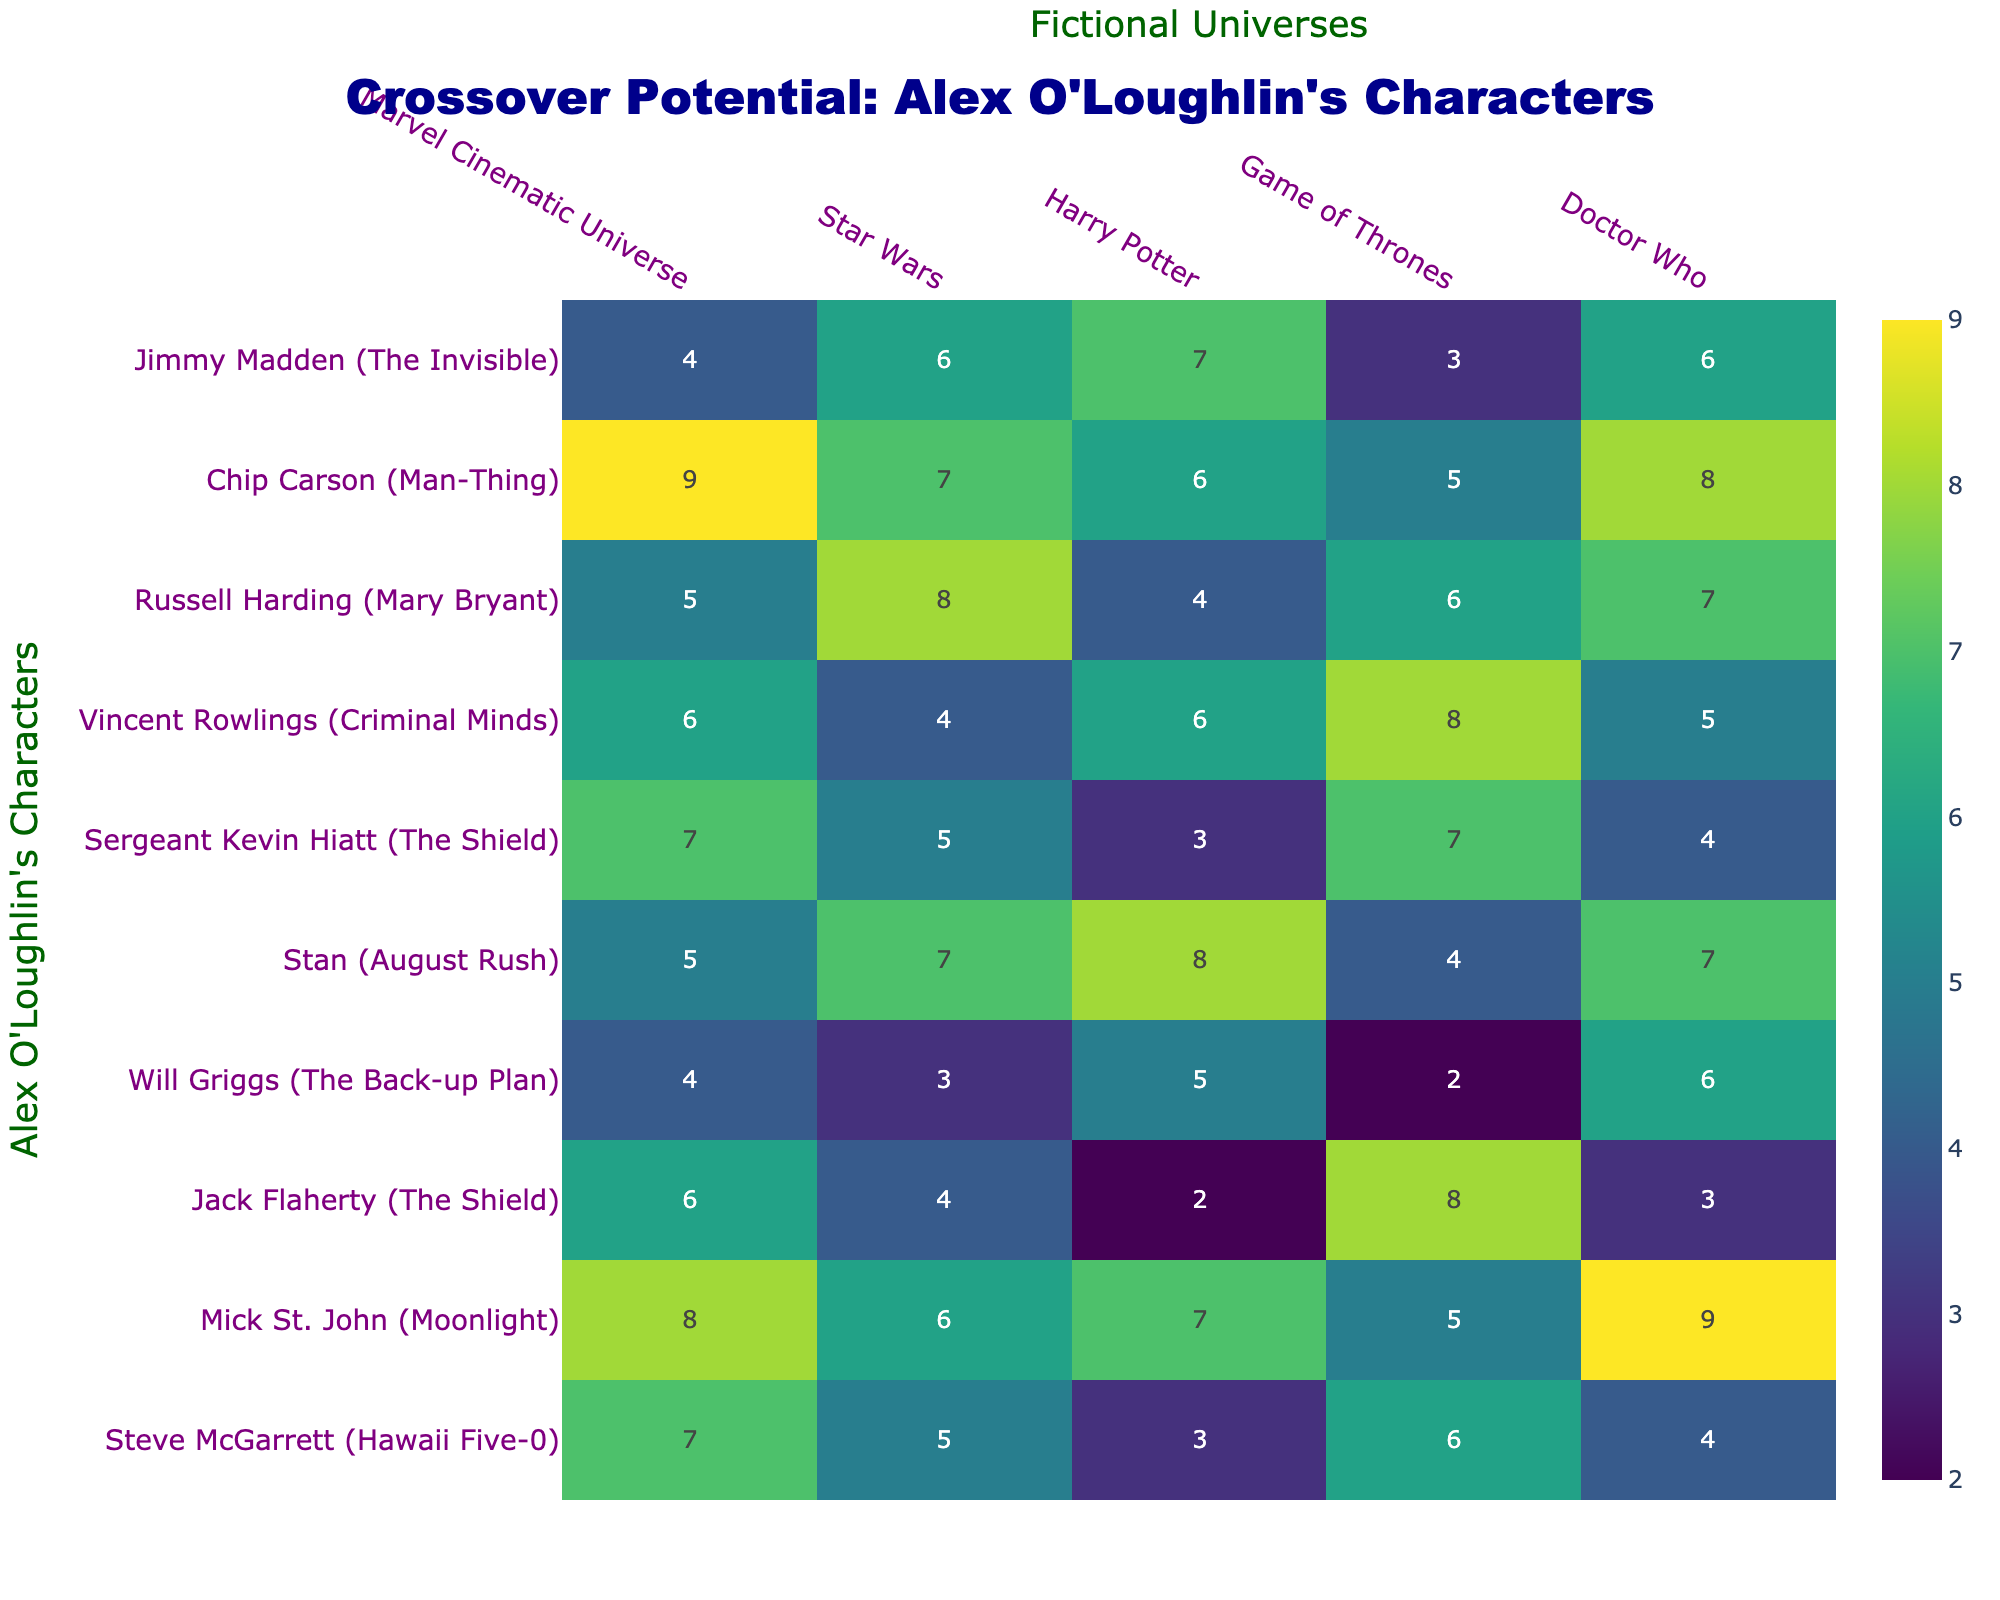What is the crossover potential of Mick St. John in the Marvel Cinematic Universe? Referring to the table, Mick St. John's crossover potential in the Marvel Cinematic Universe is explicitly listed as 8.
Answer: 8 Which character has the highest crossover potential in the Star Wars universe? Looking at the Star Wars column, Chip Carson has the highest score of 7.
Answer: Chip Carson What is the average crossover potential for Steve McGarrett across all listed universes? To find the average for Steve McGarrett, sum his scores: 7 + 5 + 3 + 6 + 4 = 25, then divide by 5 which gives 25/5 = 5.
Answer: 5 Does Jack Flaherty have a higher crossover potential in Game of Thrones or Harry Potter? Jack Flaherty's Game of Thrones potential is 8 and Harry Potter's potential is 2. Since 8 > 2, he has a higher crossover potential in Game of Thrones.
Answer: Yes Which character has the lowest crossover potential in the Harry Potter universe? By examining the Harry Potter column, Jack Flaherty shows the lowest score of 2.
Answer: Jack Flaherty If we consider the crossover potential in the Doctor Who universe, which character has a score of 9? The Doctor Who column shows that Mick St. John has a score of 9.
Answer: Mick St. John What is the crossover potential difference between Chip Carson and Jimmy Madden in the Marvel Cinematic Universe? Chip Carson's score is 9 and Jimmy Madden's score is 4. The difference is 9 - 4 = 5.
Answer: 5 Which character has the most balanced scores across the universes, and how many times does his score exceed 6? Analyzing the scores for each character, Mick St. John has 8, 6, 7, 5, 9. He has three scores (>6): 8, 7, 9.
Answer: Mick St. John, 3 times Is there any character with a consistent crossover potential of 6 across most universes? Checking the table, there is no character with the same score of 6 across multiple universes; the values vary significantly.
Answer: No Which character's crossover potential is highest for both Marvel and Star Wars combined, and what is that total? Adding for Chip Carson: 9 (Marvel) + 7 (Star Wars) = 16. For Mick St. John: 8 (Marvel) + 6 (Star Wars) = 14. Thus, Chip Carson has the highest combined potential of 16.
Answer: Chip Carson, 16 